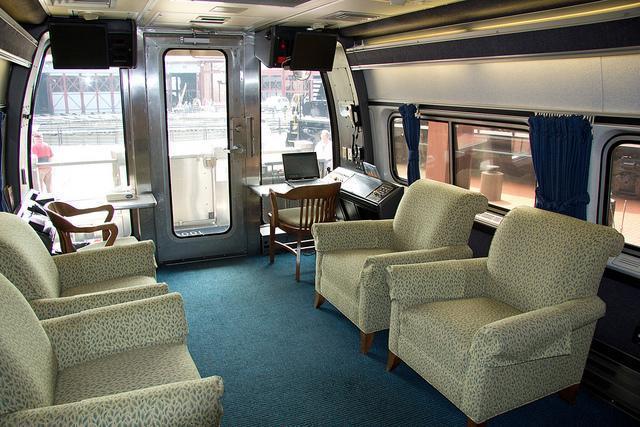How many chairs are there?
Give a very brief answer. 6. How many tvs are visible?
Give a very brief answer. 2. 